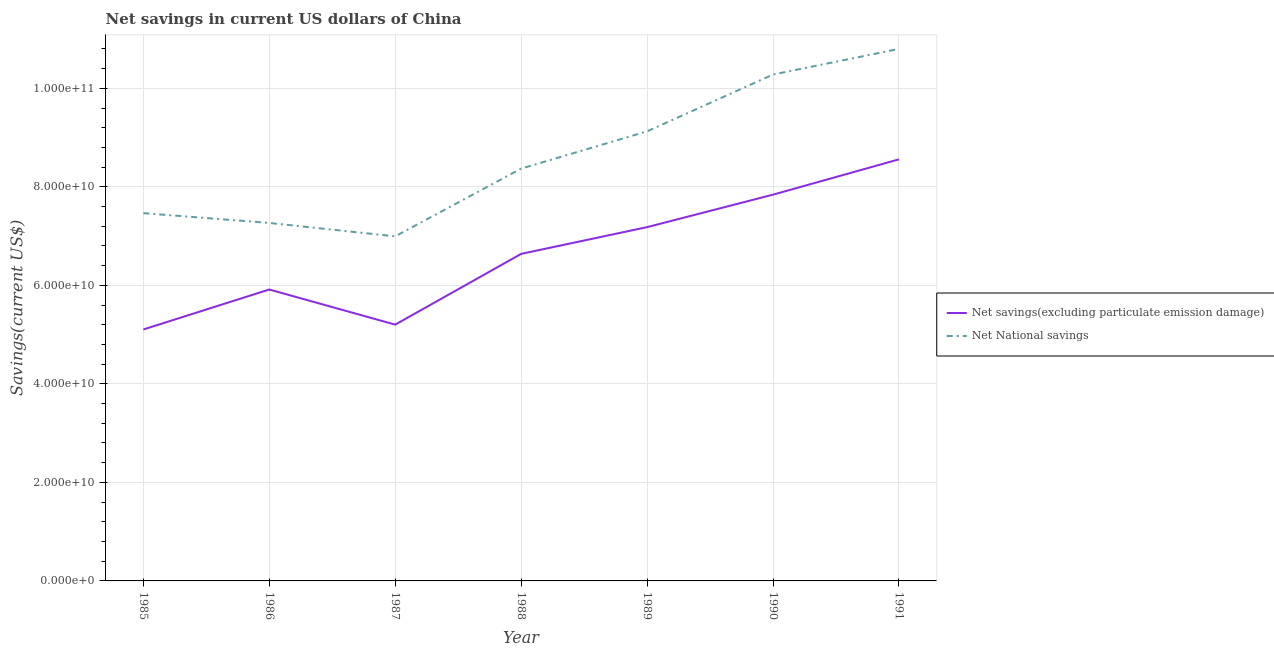What is the net savings(excluding particulate emission damage) in 1986?
Provide a short and direct response. 5.92e+1. Across all years, what is the maximum net savings(excluding particulate emission damage)?
Offer a very short reply. 8.56e+1. Across all years, what is the minimum net national savings?
Offer a terse response. 6.99e+1. In which year was the net national savings maximum?
Provide a succinct answer. 1991. What is the total net national savings in the graph?
Your response must be concise. 6.03e+11. What is the difference between the net savings(excluding particulate emission damage) in 1988 and that in 1990?
Provide a succinct answer. -1.20e+1. What is the difference between the net savings(excluding particulate emission damage) in 1986 and the net national savings in 1987?
Ensure brevity in your answer.  -1.08e+1. What is the average net savings(excluding particulate emission damage) per year?
Your response must be concise. 6.63e+1. In the year 1986, what is the difference between the net national savings and net savings(excluding particulate emission damage)?
Ensure brevity in your answer.  1.35e+1. What is the ratio of the net national savings in 1986 to that in 1990?
Your answer should be very brief. 0.71. Is the difference between the net savings(excluding particulate emission damage) in 1986 and 1991 greater than the difference between the net national savings in 1986 and 1991?
Make the answer very short. Yes. What is the difference between the highest and the second highest net savings(excluding particulate emission damage)?
Ensure brevity in your answer.  7.17e+09. What is the difference between the highest and the lowest net savings(excluding particulate emission damage)?
Your answer should be very brief. 3.45e+1. Is the net savings(excluding particulate emission damage) strictly greater than the net national savings over the years?
Keep it short and to the point. No. Is the net savings(excluding particulate emission damage) strictly less than the net national savings over the years?
Provide a short and direct response. Yes. How many lines are there?
Offer a very short reply. 2. How many years are there in the graph?
Your answer should be very brief. 7. Are the values on the major ticks of Y-axis written in scientific E-notation?
Your response must be concise. Yes. Does the graph contain any zero values?
Your answer should be compact. No. Does the graph contain grids?
Your answer should be very brief. Yes. Where does the legend appear in the graph?
Your answer should be compact. Center right. How are the legend labels stacked?
Give a very brief answer. Vertical. What is the title of the graph?
Provide a succinct answer. Net savings in current US dollars of China. What is the label or title of the Y-axis?
Your answer should be very brief. Savings(current US$). What is the Savings(current US$) in Net savings(excluding particulate emission damage) in 1985?
Your answer should be compact. 5.10e+1. What is the Savings(current US$) of Net National savings in 1985?
Keep it short and to the point. 7.47e+1. What is the Savings(current US$) of Net savings(excluding particulate emission damage) in 1986?
Offer a very short reply. 5.92e+1. What is the Savings(current US$) of Net National savings in 1986?
Offer a terse response. 7.27e+1. What is the Savings(current US$) of Net savings(excluding particulate emission damage) in 1987?
Your answer should be compact. 5.20e+1. What is the Savings(current US$) of Net National savings in 1987?
Give a very brief answer. 6.99e+1. What is the Savings(current US$) in Net savings(excluding particulate emission damage) in 1988?
Keep it short and to the point. 6.64e+1. What is the Savings(current US$) of Net National savings in 1988?
Your response must be concise. 8.37e+1. What is the Savings(current US$) of Net savings(excluding particulate emission damage) in 1989?
Make the answer very short. 7.18e+1. What is the Savings(current US$) in Net National savings in 1989?
Give a very brief answer. 9.13e+1. What is the Savings(current US$) in Net savings(excluding particulate emission damage) in 1990?
Keep it short and to the point. 7.84e+1. What is the Savings(current US$) of Net National savings in 1990?
Offer a terse response. 1.03e+11. What is the Savings(current US$) in Net savings(excluding particulate emission damage) in 1991?
Provide a succinct answer. 8.56e+1. What is the Savings(current US$) of Net National savings in 1991?
Give a very brief answer. 1.08e+11. Across all years, what is the maximum Savings(current US$) of Net savings(excluding particulate emission damage)?
Keep it short and to the point. 8.56e+1. Across all years, what is the maximum Savings(current US$) of Net National savings?
Your answer should be very brief. 1.08e+11. Across all years, what is the minimum Savings(current US$) of Net savings(excluding particulate emission damage)?
Your response must be concise. 5.10e+1. Across all years, what is the minimum Savings(current US$) in Net National savings?
Provide a succinct answer. 6.99e+1. What is the total Savings(current US$) in Net savings(excluding particulate emission damage) in the graph?
Offer a terse response. 4.64e+11. What is the total Savings(current US$) of Net National savings in the graph?
Provide a short and direct response. 6.03e+11. What is the difference between the Savings(current US$) in Net savings(excluding particulate emission damage) in 1985 and that in 1986?
Provide a short and direct response. -8.11e+09. What is the difference between the Savings(current US$) in Net National savings in 1985 and that in 1986?
Offer a very short reply. 1.99e+09. What is the difference between the Savings(current US$) of Net savings(excluding particulate emission damage) in 1985 and that in 1987?
Provide a short and direct response. -9.86e+08. What is the difference between the Savings(current US$) in Net National savings in 1985 and that in 1987?
Provide a succinct answer. 4.71e+09. What is the difference between the Savings(current US$) in Net savings(excluding particulate emission damage) in 1985 and that in 1988?
Provide a succinct answer. -1.53e+1. What is the difference between the Savings(current US$) of Net National savings in 1985 and that in 1988?
Provide a succinct answer. -9.04e+09. What is the difference between the Savings(current US$) in Net savings(excluding particulate emission damage) in 1985 and that in 1989?
Make the answer very short. -2.08e+1. What is the difference between the Savings(current US$) of Net National savings in 1985 and that in 1989?
Provide a succinct answer. -1.66e+1. What is the difference between the Savings(current US$) in Net savings(excluding particulate emission damage) in 1985 and that in 1990?
Offer a very short reply. -2.74e+1. What is the difference between the Savings(current US$) in Net National savings in 1985 and that in 1990?
Your answer should be very brief. -2.81e+1. What is the difference between the Savings(current US$) of Net savings(excluding particulate emission damage) in 1985 and that in 1991?
Ensure brevity in your answer.  -3.45e+1. What is the difference between the Savings(current US$) in Net National savings in 1985 and that in 1991?
Offer a very short reply. -3.33e+1. What is the difference between the Savings(current US$) in Net savings(excluding particulate emission damage) in 1986 and that in 1987?
Your answer should be compact. 7.13e+09. What is the difference between the Savings(current US$) of Net National savings in 1986 and that in 1987?
Keep it short and to the point. 2.72e+09. What is the difference between the Savings(current US$) of Net savings(excluding particulate emission damage) in 1986 and that in 1988?
Your answer should be very brief. -7.23e+09. What is the difference between the Savings(current US$) of Net National savings in 1986 and that in 1988?
Your response must be concise. -1.10e+1. What is the difference between the Savings(current US$) in Net savings(excluding particulate emission damage) in 1986 and that in 1989?
Offer a very short reply. -1.27e+1. What is the difference between the Savings(current US$) of Net National savings in 1986 and that in 1989?
Make the answer very short. -1.86e+1. What is the difference between the Savings(current US$) in Net savings(excluding particulate emission damage) in 1986 and that in 1990?
Give a very brief answer. -1.93e+1. What is the difference between the Savings(current US$) in Net National savings in 1986 and that in 1990?
Offer a very short reply. -3.01e+1. What is the difference between the Savings(current US$) of Net savings(excluding particulate emission damage) in 1986 and that in 1991?
Make the answer very short. -2.64e+1. What is the difference between the Savings(current US$) in Net National savings in 1986 and that in 1991?
Provide a short and direct response. -3.53e+1. What is the difference between the Savings(current US$) in Net savings(excluding particulate emission damage) in 1987 and that in 1988?
Keep it short and to the point. -1.44e+1. What is the difference between the Savings(current US$) of Net National savings in 1987 and that in 1988?
Your response must be concise. -1.38e+1. What is the difference between the Savings(current US$) of Net savings(excluding particulate emission damage) in 1987 and that in 1989?
Offer a very short reply. -1.98e+1. What is the difference between the Savings(current US$) of Net National savings in 1987 and that in 1989?
Offer a terse response. -2.13e+1. What is the difference between the Savings(current US$) of Net savings(excluding particulate emission damage) in 1987 and that in 1990?
Keep it short and to the point. -2.64e+1. What is the difference between the Savings(current US$) of Net National savings in 1987 and that in 1990?
Offer a terse response. -3.29e+1. What is the difference between the Savings(current US$) of Net savings(excluding particulate emission damage) in 1987 and that in 1991?
Give a very brief answer. -3.36e+1. What is the difference between the Savings(current US$) in Net National savings in 1987 and that in 1991?
Give a very brief answer. -3.81e+1. What is the difference between the Savings(current US$) in Net savings(excluding particulate emission damage) in 1988 and that in 1989?
Keep it short and to the point. -5.43e+09. What is the difference between the Savings(current US$) of Net National savings in 1988 and that in 1989?
Ensure brevity in your answer.  -7.56e+09. What is the difference between the Savings(current US$) in Net savings(excluding particulate emission damage) in 1988 and that in 1990?
Ensure brevity in your answer.  -1.20e+1. What is the difference between the Savings(current US$) of Net National savings in 1988 and that in 1990?
Your response must be concise. -1.91e+1. What is the difference between the Savings(current US$) of Net savings(excluding particulate emission damage) in 1988 and that in 1991?
Your response must be concise. -1.92e+1. What is the difference between the Savings(current US$) of Net National savings in 1988 and that in 1991?
Ensure brevity in your answer.  -2.43e+1. What is the difference between the Savings(current US$) of Net savings(excluding particulate emission damage) in 1989 and that in 1990?
Your answer should be compact. -6.60e+09. What is the difference between the Savings(current US$) of Net National savings in 1989 and that in 1990?
Keep it short and to the point. -1.15e+1. What is the difference between the Savings(current US$) in Net savings(excluding particulate emission damage) in 1989 and that in 1991?
Provide a succinct answer. -1.38e+1. What is the difference between the Savings(current US$) of Net National savings in 1989 and that in 1991?
Your answer should be compact. -1.67e+1. What is the difference between the Savings(current US$) of Net savings(excluding particulate emission damage) in 1990 and that in 1991?
Your answer should be very brief. -7.17e+09. What is the difference between the Savings(current US$) of Net National savings in 1990 and that in 1991?
Ensure brevity in your answer.  -5.20e+09. What is the difference between the Savings(current US$) in Net savings(excluding particulate emission damage) in 1985 and the Savings(current US$) in Net National savings in 1986?
Give a very brief answer. -2.16e+1. What is the difference between the Savings(current US$) in Net savings(excluding particulate emission damage) in 1985 and the Savings(current US$) in Net National savings in 1987?
Offer a terse response. -1.89e+1. What is the difference between the Savings(current US$) in Net savings(excluding particulate emission damage) in 1985 and the Savings(current US$) in Net National savings in 1988?
Make the answer very short. -3.27e+1. What is the difference between the Savings(current US$) of Net savings(excluding particulate emission damage) in 1985 and the Savings(current US$) of Net National savings in 1989?
Your response must be concise. -4.02e+1. What is the difference between the Savings(current US$) of Net savings(excluding particulate emission damage) in 1985 and the Savings(current US$) of Net National savings in 1990?
Provide a short and direct response. -5.18e+1. What is the difference between the Savings(current US$) of Net savings(excluding particulate emission damage) in 1985 and the Savings(current US$) of Net National savings in 1991?
Keep it short and to the point. -5.70e+1. What is the difference between the Savings(current US$) in Net savings(excluding particulate emission damage) in 1986 and the Savings(current US$) in Net National savings in 1987?
Your answer should be compact. -1.08e+1. What is the difference between the Savings(current US$) in Net savings(excluding particulate emission damage) in 1986 and the Savings(current US$) in Net National savings in 1988?
Keep it short and to the point. -2.45e+1. What is the difference between the Savings(current US$) in Net savings(excluding particulate emission damage) in 1986 and the Savings(current US$) in Net National savings in 1989?
Your answer should be compact. -3.21e+1. What is the difference between the Savings(current US$) of Net savings(excluding particulate emission damage) in 1986 and the Savings(current US$) of Net National savings in 1990?
Keep it short and to the point. -4.36e+1. What is the difference between the Savings(current US$) of Net savings(excluding particulate emission damage) in 1986 and the Savings(current US$) of Net National savings in 1991?
Make the answer very short. -4.88e+1. What is the difference between the Savings(current US$) of Net savings(excluding particulate emission damage) in 1987 and the Savings(current US$) of Net National savings in 1988?
Keep it short and to the point. -3.17e+1. What is the difference between the Savings(current US$) in Net savings(excluding particulate emission damage) in 1987 and the Savings(current US$) in Net National savings in 1989?
Offer a very short reply. -3.92e+1. What is the difference between the Savings(current US$) in Net savings(excluding particulate emission damage) in 1987 and the Savings(current US$) in Net National savings in 1990?
Make the answer very short. -5.08e+1. What is the difference between the Savings(current US$) in Net savings(excluding particulate emission damage) in 1987 and the Savings(current US$) in Net National savings in 1991?
Keep it short and to the point. -5.60e+1. What is the difference between the Savings(current US$) of Net savings(excluding particulate emission damage) in 1988 and the Savings(current US$) of Net National savings in 1989?
Make the answer very short. -2.49e+1. What is the difference between the Savings(current US$) in Net savings(excluding particulate emission damage) in 1988 and the Savings(current US$) in Net National savings in 1990?
Your answer should be very brief. -3.64e+1. What is the difference between the Savings(current US$) in Net savings(excluding particulate emission damage) in 1988 and the Savings(current US$) in Net National savings in 1991?
Offer a very short reply. -4.16e+1. What is the difference between the Savings(current US$) in Net savings(excluding particulate emission damage) in 1989 and the Savings(current US$) in Net National savings in 1990?
Ensure brevity in your answer.  -3.10e+1. What is the difference between the Savings(current US$) in Net savings(excluding particulate emission damage) in 1989 and the Savings(current US$) in Net National savings in 1991?
Ensure brevity in your answer.  -3.62e+1. What is the difference between the Savings(current US$) of Net savings(excluding particulate emission damage) in 1990 and the Savings(current US$) of Net National savings in 1991?
Offer a terse response. -2.96e+1. What is the average Savings(current US$) of Net savings(excluding particulate emission damage) per year?
Keep it short and to the point. 6.63e+1. What is the average Savings(current US$) of Net National savings per year?
Keep it short and to the point. 8.61e+1. In the year 1985, what is the difference between the Savings(current US$) in Net savings(excluding particulate emission damage) and Savings(current US$) in Net National savings?
Provide a short and direct response. -2.36e+1. In the year 1986, what is the difference between the Savings(current US$) in Net savings(excluding particulate emission damage) and Savings(current US$) in Net National savings?
Offer a terse response. -1.35e+1. In the year 1987, what is the difference between the Savings(current US$) of Net savings(excluding particulate emission damage) and Savings(current US$) of Net National savings?
Offer a terse response. -1.79e+1. In the year 1988, what is the difference between the Savings(current US$) in Net savings(excluding particulate emission damage) and Savings(current US$) in Net National savings?
Offer a very short reply. -1.73e+1. In the year 1989, what is the difference between the Savings(current US$) of Net savings(excluding particulate emission damage) and Savings(current US$) of Net National savings?
Give a very brief answer. -1.94e+1. In the year 1990, what is the difference between the Savings(current US$) in Net savings(excluding particulate emission damage) and Savings(current US$) in Net National savings?
Your answer should be very brief. -2.44e+1. In the year 1991, what is the difference between the Savings(current US$) in Net savings(excluding particulate emission damage) and Savings(current US$) in Net National savings?
Your answer should be very brief. -2.24e+1. What is the ratio of the Savings(current US$) of Net savings(excluding particulate emission damage) in 1985 to that in 1986?
Your answer should be very brief. 0.86. What is the ratio of the Savings(current US$) of Net National savings in 1985 to that in 1986?
Your response must be concise. 1.03. What is the ratio of the Savings(current US$) of Net savings(excluding particulate emission damage) in 1985 to that in 1987?
Your answer should be compact. 0.98. What is the ratio of the Savings(current US$) in Net National savings in 1985 to that in 1987?
Your response must be concise. 1.07. What is the ratio of the Savings(current US$) of Net savings(excluding particulate emission damage) in 1985 to that in 1988?
Your answer should be compact. 0.77. What is the ratio of the Savings(current US$) in Net National savings in 1985 to that in 1988?
Keep it short and to the point. 0.89. What is the ratio of the Savings(current US$) in Net savings(excluding particulate emission damage) in 1985 to that in 1989?
Provide a succinct answer. 0.71. What is the ratio of the Savings(current US$) of Net National savings in 1985 to that in 1989?
Give a very brief answer. 0.82. What is the ratio of the Savings(current US$) of Net savings(excluding particulate emission damage) in 1985 to that in 1990?
Your answer should be very brief. 0.65. What is the ratio of the Savings(current US$) of Net National savings in 1985 to that in 1990?
Your response must be concise. 0.73. What is the ratio of the Savings(current US$) in Net savings(excluding particulate emission damage) in 1985 to that in 1991?
Make the answer very short. 0.6. What is the ratio of the Savings(current US$) of Net National savings in 1985 to that in 1991?
Provide a short and direct response. 0.69. What is the ratio of the Savings(current US$) of Net savings(excluding particulate emission damage) in 1986 to that in 1987?
Offer a very short reply. 1.14. What is the ratio of the Savings(current US$) of Net National savings in 1986 to that in 1987?
Provide a succinct answer. 1.04. What is the ratio of the Savings(current US$) of Net savings(excluding particulate emission damage) in 1986 to that in 1988?
Provide a succinct answer. 0.89. What is the ratio of the Savings(current US$) in Net National savings in 1986 to that in 1988?
Make the answer very short. 0.87. What is the ratio of the Savings(current US$) of Net savings(excluding particulate emission damage) in 1986 to that in 1989?
Offer a very short reply. 0.82. What is the ratio of the Savings(current US$) in Net National savings in 1986 to that in 1989?
Make the answer very short. 0.8. What is the ratio of the Savings(current US$) in Net savings(excluding particulate emission damage) in 1986 to that in 1990?
Provide a short and direct response. 0.75. What is the ratio of the Savings(current US$) of Net National savings in 1986 to that in 1990?
Your response must be concise. 0.71. What is the ratio of the Savings(current US$) of Net savings(excluding particulate emission damage) in 1986 to that in 1991?
Keep it short and to the point. 0.69. What is the ratio of the Savings(current US$) of Net National savings in 1986 to that in 1991?
Keep it short and to the point. 0.67. What is the ratio of the Savings(current US$) in Net savings(excluding particulate emission damage) in 1987 to that in 1988?
Offer a very short reply. 0.78. What is the ratio of the Savings(current US$) of Net National savings in 1987 to that in 1988?
Give a very brief answer. 0.84. What is the ratio of the Savings(current US$) in Net savings(excluding particulate emission damage) in 1987 to that in 1989?
Provide a short and direct response. 0.72. What is the ratio of the Savings(current US$) of Net National savings in 1987 to that in 1989?
Your answer should be very brief. 0.77. What is the ratio of the Savings(current US$) of Net savings(excluding particulate emission damage) in 1987 to that in 1990?
Ensure brevity in your answer.  0.66. What is the ratio of the Savings(current US$) in Net National savings in 1987 to that in 1990?
Provide a succinct answer. 0.68. What is the ratio of the Savings(current US$) of Net savings(excluding particulate emission damage) in 1987 to that in 1991?
Give a very brief answer. 0.61. What is the ratio of the Savings(current US$) in Net National savings in 1987 to that in 1991?
Make the answer very short. 0.65. What is the ratio of the Savings(current US$) of Net savings(excluding particulate emission damage) in 1988 to that in 1989?
Give a very brief answer. 0.92. What is the ratio of the Savings(current US$) in Net National savings in 1988 to that in 1989?
Give a very brief answer. 0.92. What is the ratio of the Savings(current US$) in Net savings(excluding particulate emission damage) in 1988 to that in 1990?
Your answer should be compact. 0.85. What is the ratio of the Savings(current US$) of Net National savings in 1988 to that in 1990?
Give a very brief answer. 0.81. What is the ratio of the Savings(current US$) of Net savings(excluding particulate emission damage) in 1988 to that in 1991?
Offer a very short reply. 0.78. What is the ratio of the Savings(current US$) in Net National savings in 1988 to that in 1991?
Your response must be concise. 0.78. What is the ratio of the Savings(current US$) of Net savings(excluding particulate emission damage) in 1989 to that in 1990?
Your response must be concise. 0.92. What is the ratio of the Savings(current US$) in Net National savings in 1989 to that in 1990?
Offer a very short reply. 0.89. What is the ratio of the Savings(current US$) of Net savings(excluding particulate emission damage) in 1989 to that in 1991?
Your answer should be compact. 0.84. What is the ratio of the Savings(current US$) of Net National savings in 1989 to that in 1991?
Your answer should be very brief. 0.84. What is the ratio of the Savings(current US$) in Net savings(excluding particulate emission damage) in 1990 to that in 1991?
Your answer should be very brief. 0.92. What is the ratio of the Savings(current US$) in Net National savings in 1990 to that in 1991?
Offer a very short reply. 0.95. What is the difference between the highest and the second highest Savings(current US$) in Net savings(excluding particulate emission damage)?
Your answer should be compact. 7.17e+09. What is the difference between the highest and the second highest Savings(current US$) of Net National savings?
Provide a succinct answer. 5.20e+09. What is the difference between the highest and the lowest Savings(current US$) of Net savings(excluding particulate emission damage)?
Provide a short and direct response. 3.45e+1. What is the difference between the highest and the lowest Savings(current US$) in Net National savings?
Your answer should be compact. 3.81e+1. 